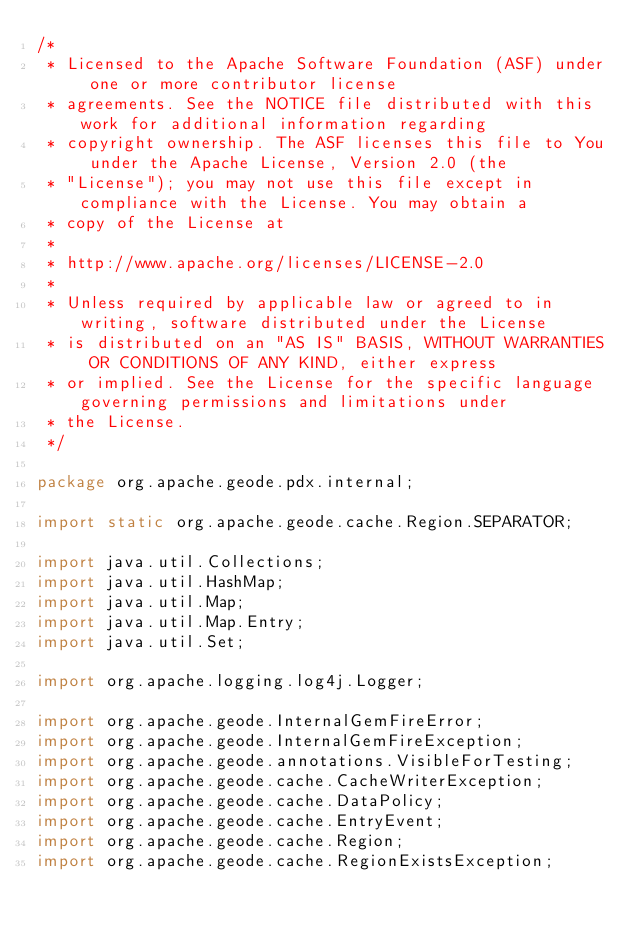<code> <loc_0><loc_0><loc_500><loc_500><_Java_>/*
 * Licensed to the Apache Software Foundation (ASF) under one or more contributor license
 * agreements. See the NOTICE file distributed with this work for additional information regarding
 * copyright ownership. The ASF licenses this file to You under the Apache License, Version 2.0 (the
 * "License"); you may not use this file except in compliance with the License. You may obtain a
 * copy of the License at
 *
 * http://www.apache.org/licenses/LICENSE-2.0
 *
 * Unless required by applicable law or agreed to in writing, software distributed under the License
 * is distributed on an "AS IS" BASIS, WITHOUT WARRANTIES OR CONDITIONS OF ANY KIND, either express
 * or implied. See the License for the specific language governing permissions and limitations under
 * the License.
 */

package org.apache.geode.pdx.internal;

import static org.apache.geode.cache.Region.SEPARATOR;

import java.util.Collections;
import java.util.HashMap;
import java.util.Map;
import java.util.Map.Entry;
import java.util.Set;

import org.apache.logging.log4j.Logger;

import org.apache.geode.InternalGemFireError;
import org.apache.geode.InternalGemFireException;
import org.apache.geode.annotations.VisibleForTesting;
import org.apache.geode.cache.CacheWriterException;
import org.apache.geode.cache.DataPolicy;
import org.apache.geode.cache.EntryEvent;
import org.apache.geode.cache.Region;
import org.apache.geode.cache.RegionExistsException;</code> 